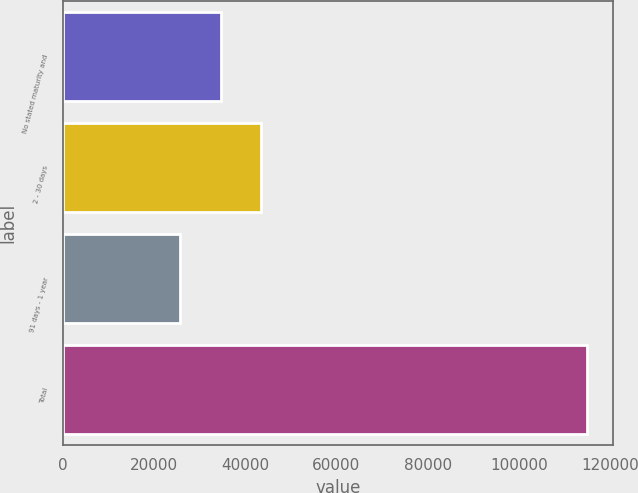Convert chart to OTSL. <chart><loc_0><loc_0><loc_500><loc_500><bar_chart><fcel>No stated maturity and<fcel>2 - 30 days<fcel>91 days - 1 year<fcel>Total<nl><fcel>34617.9<fcel>43544.8<fcel>25691<fcel>114960<nl></chart> 